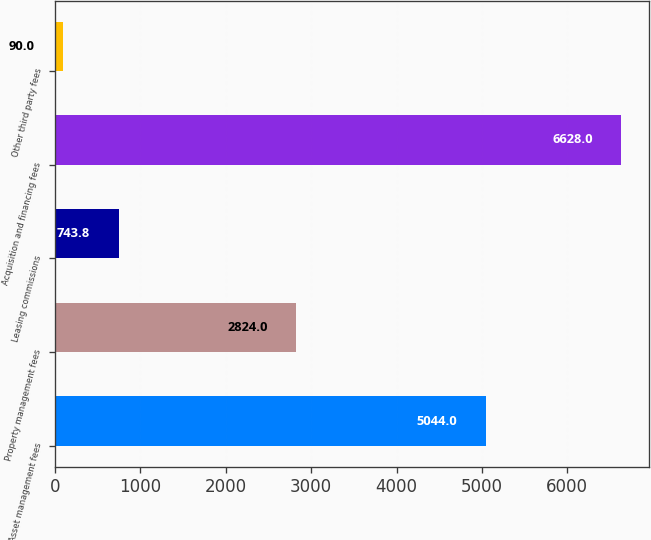Convert chart. <chart><loc_0><loc_0><loc_500><loc_500><bar_chart><fcel>Asset management fees<fcel>Property management fees<fcel>Leasing commissions<fcel>Acquisition and financing fees<fcel>Other third party fees<nl><fcel>5044<fcel>2824<fcel>743.8<fcel>6628<fcel>90<nl></chart> 